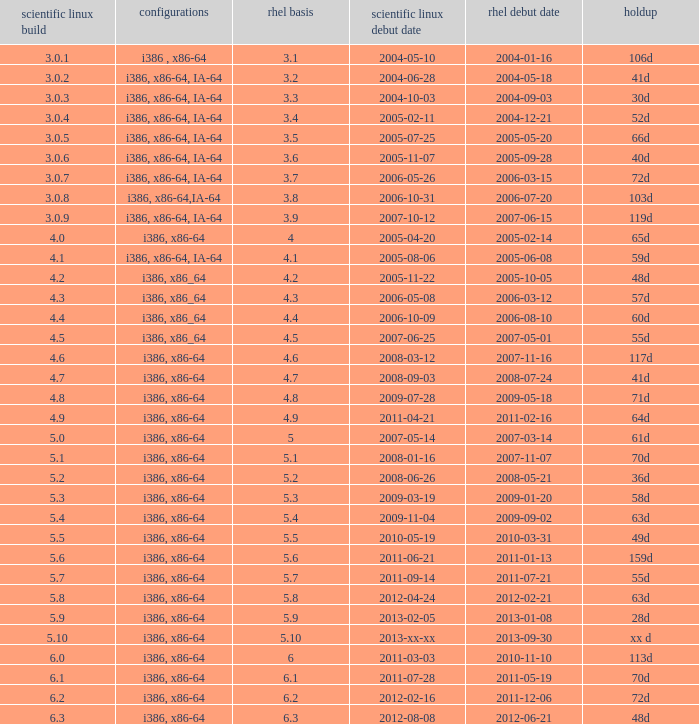Name the scientific linux release when delay is 28d 5.9. 